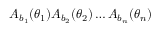<formula> <loc_0><loc_0><loc_500><loc_500>A _ { b _ { 1 } } ( \theta _ { 1 } ) A _ { b _ { 2 } } ( \theta _ { 2 } ) \dots A _ { b _ { n } } ( \theta _ { n } )</formula> 